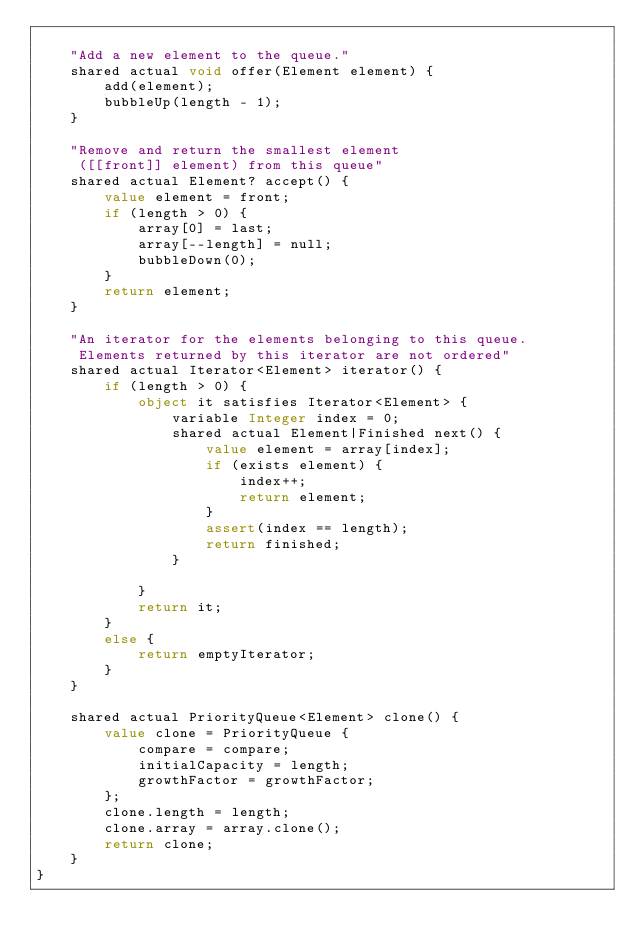<code> <loc_0><loc_0><loc_500><loc_500><_Ceylon_>    
    "Add a new element to the queue."
    shared actual void offer(Element element) {
        add(element);
        bubbleUp(length - 1);
    }
    
    "Remove and return the smallest element
     ([[front]] element) from this queue"
    shared actual Element? accept() {
        value element = front;
        if (length > 0) {
            array[0] = last;
            array[--length] = null;
            bubbleDown(0);
        }
        return element;
    }
    
    "An iterator for the elements belonging to this queue.
     Elements returned by this iterator are not ordered"
    shared actual Iterator<Element> iterator() {
        if (length > 0) {
            object it satisfies Iterator<Element> {
                variable Integer index = 0;
                shared actual Element|Finished next() {
                    value element = array[index];
                    if (exists element) {
                        index++;
                        return element;
                    }
                    assert(index == length);
                    return finished;
                }
                
            }
            return it;
        }
        else {
            return emptyIterator;
        }
    }
    
    shared actual PriorityQueue<Element> clone() {
        value clone = PriorityQueue {
            compare = compare;
            initialCapacity = length;
            growthFactor = growthFactor;
        };
        clone.length = length;
        clone.array = array.clone();
        return clone;
    }
}
</code> 